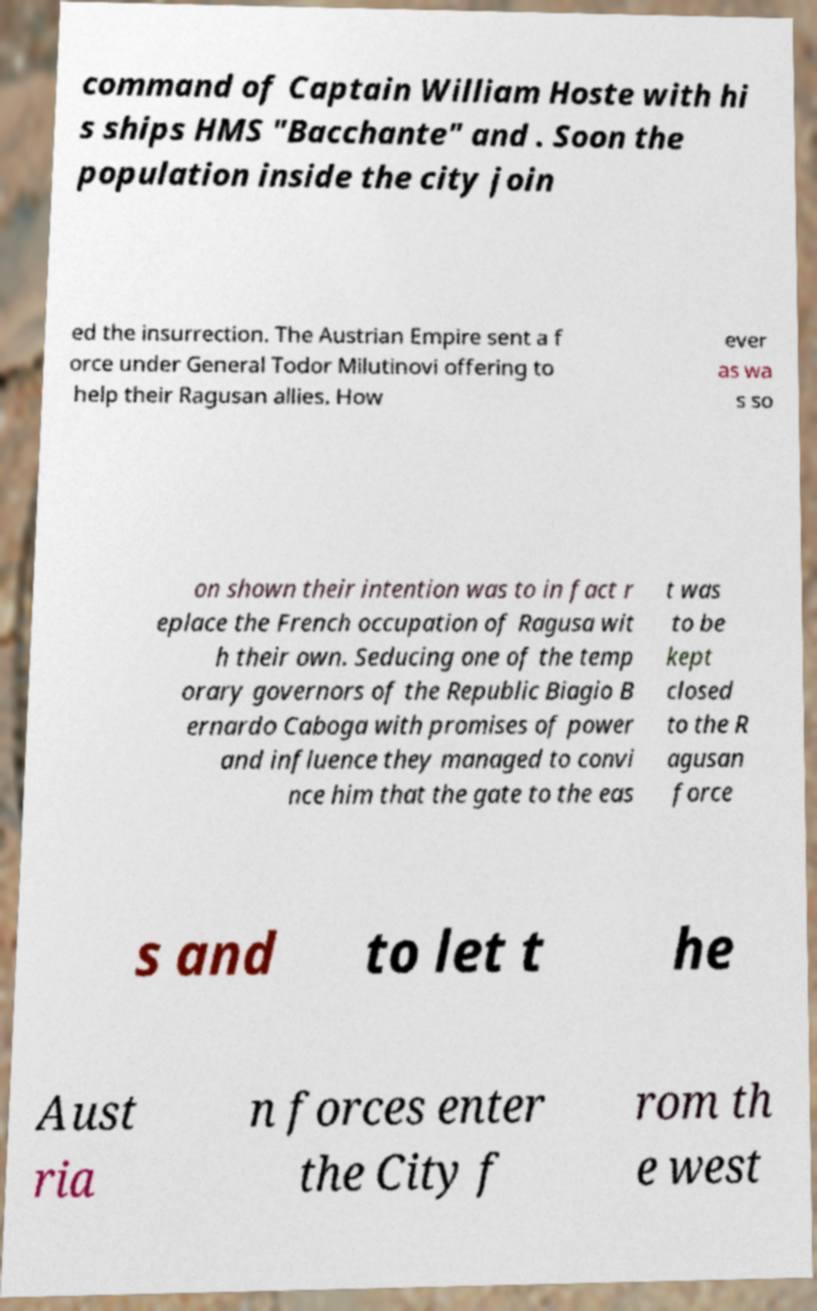Can you accurately transcribe the text from the provided image for me? command of Captain William Hoste with hi s ships HMS "Bacchante" and . Soon the population inside the city join ed the insurrection. The Austrian Empire sent a f orce under General Todor Milutinovi offering to help their Ragusan allies. How ever as wa s so on shown their intention was to in fact r eplace the French occupation of Ragusa wit h their own. Seducing one of the temp orary governors of the Republic Biagio B ernardo Caboga with promises of power and influence they managed to convi nce him that the gate to the eas t was to be kept closed to the R agusan force s and to let t he Aust ria n forces enter the City f rom th e west 